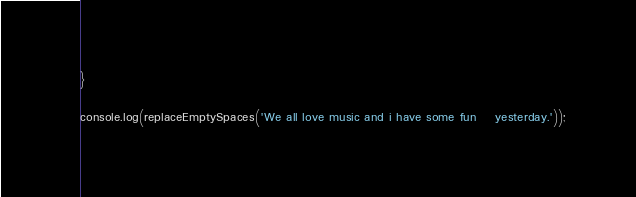Convert code to text. <code><loc_0><loc_0><loc_500><loc_500><_JavaScript_>}

console.log(replaceEmptySpaces('We all love music and i have some fun    yesterday.'));</code> 